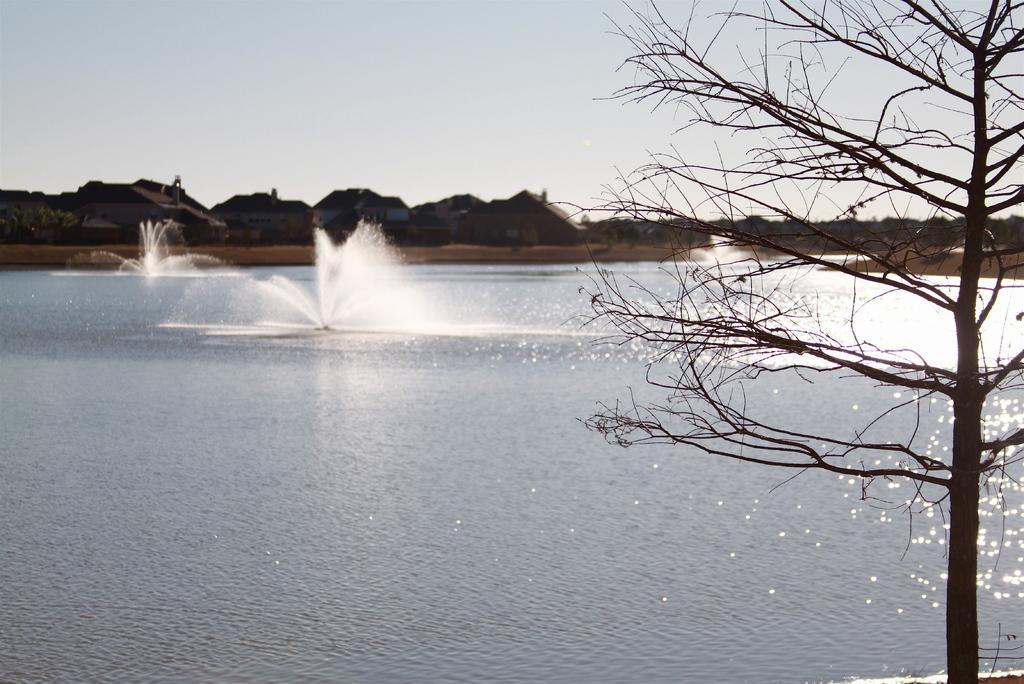In one or two sentences, can you explain what this image depicts? On the right side, there is a tree. In the background, there are trees and buildings on the ground and there are clouds in the sky. 